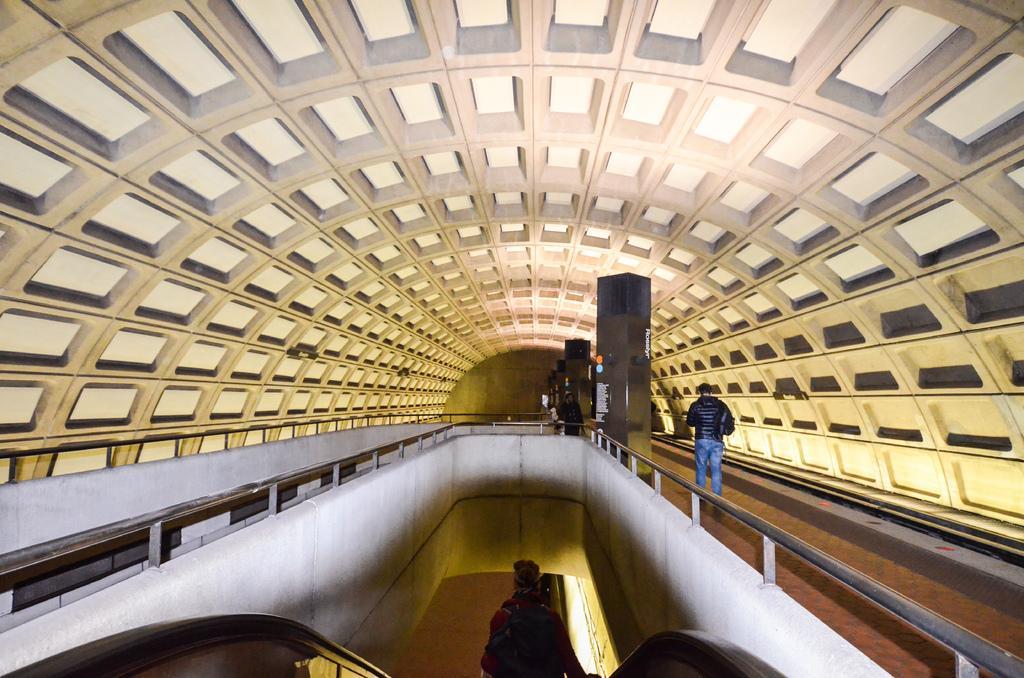Could you give a brief overview of what you see in this image? This is the picture of a building. In the middle of the image there is a person standing on the escalator. On the right side of the image there is a person walking behind the railing. On the left side of the image there is a railing. At the top there is a roof. 